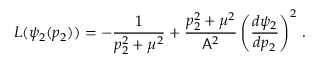<formula> <loc_0><loc_0><loc_500><loc_500>L ( \psi _ { 2 } ( p _ { 2 } ) ) = - \frac { 1 } { p _ { 2 } ^ { 2 } + \mu ^ { 2 } } + \frac { p _ { 2 } ^ { 2 } + \mu ^ { 2 } } { A ^ { 2 } } \left ( \frac { d \psi _ { 2 } } { d p _ { 2 } } \right ) ^ { 2 } \, .</formula> 